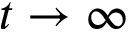Convert formula to latex. <formula><loc_0><loc_0><loc_500><loc_500>t \rightarrow \infty</formula> 